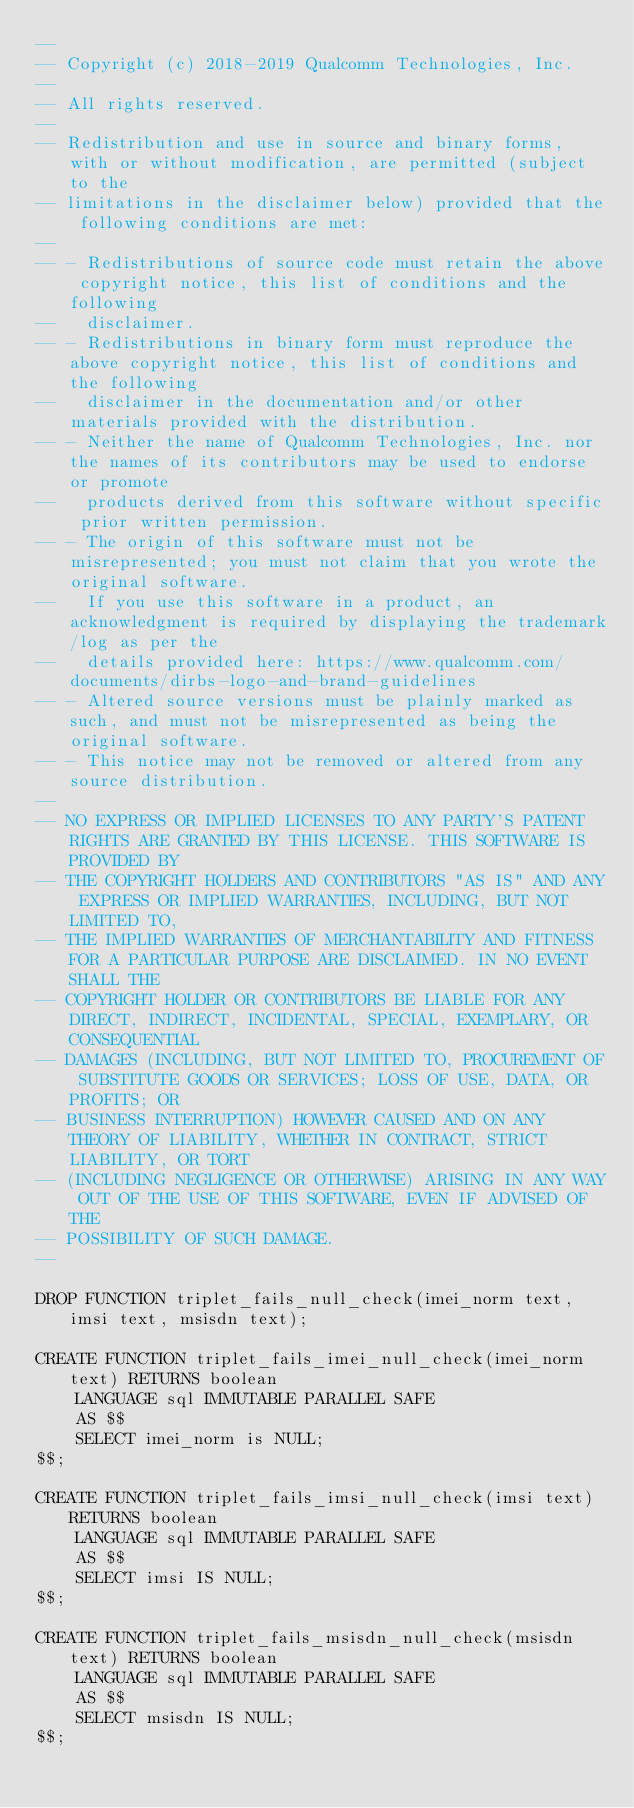<code> <loc_0><loc_0><loc_500><loc_500><_SQL_>--
-- Copyright (c) 2018-2019 Qualcomm Technologies, Inc.
--
-- All rights reserved.
--
-- Redistribution and use in source and binary forms, with or without modification, are permitted (subject to the
-- limitations in the disclaimer below) provided that the following conditions are met:
--
-- - Redistributions of source code must retain the above copyright notice, this list of conditions and the following
--   disclaimer.
-- - Redistributions in binary form must reproduce the above copyright notice, this list of conditions and the following
--   disclaimer in the documentation and/or other materials provided with the distribution.
-- - Neither the name of Qualcomm Technologies, Inc. nor the names of its contributors may be used to endorse or promote
--   products derived from this software without specific prior written permission.
-- - The origin of this software must not be misrepresented; you must not claim that you wrote the original software.
--   If you use this software in a product, an acknowledgment is required by displaying the trademark/log as per the
--   details provided here: https://www.qualcomm.com/documents/dirbs-logo-and-brand-guidelines
-- - Altered source versions must be plainly marked as such, and must not be misrepresented as being the original software.
-- - This notice may not be removed or altered from any source distribution.
--
-- NO EXPRESS OR IMPLIED LICENSES TO ANY PARTY'S PATENT RIGHTS ARE GRANTED BY THIS LICENSE. THIS SOFTWARE IS PROVIDED BY
-- THE COPYRIGHT HOLDERS AND CONTRIBUTORS "AS IS" AND ANY EXPRESS OR IMPLIED WARRANTIES, INCLUDING, BUT NOT LIMITED TO,
-- THE IMPLIED WARRANTIES OF MERCHANTABILITY AND FITNESS FOR A PARTICULAR PURPOSE ARE DISCLAIMED. IN NO EVENT SHALL THE
-- COPYRIGHT HOLDER OR CONTRIBUTORS BE LIABLE FOR ANY DIRECT, INDIRECT, INCIDENTAL, SPECIAL, EXEMPLARY, OR CONSEQUENTIAL
-- DAMAGES (INCLUDING, BUT NOT LIMITED TO, PROCUREMENT OF SUBSTITUTE GOODS OR SERVICES; LOSS OF USE, DATA, OR PROFITS; OR
-- BUSINESS INTERRUPTION) HOWEVER CAUSED AND ON ANY THEORY OF LIABILITY, WHETHER IN CONTRACT, STRICT LIABILITY, OR TORT
-- (INCLUDING NEGLIGENCE OR OTHERWISE) ARISING IN ANY WAY OUT OF THE USE OF THIS SOFTWARE, EVEN IF ADVISED OF THE
-- POSSIBILITY OF SUCH DAMAGE.
--

DROP FUNCTION triplet_fails_null_check(imei_norm text, imsi text, msisdn text);

CREATE FUNCTION triplet_fails_imei_null_check(imei_norm text) RETURNS boolean
    LANGUAGE sql IMMUTABLE PARALLEL SAFE
    AS $$
    SELECT imei_norm is NULL;
$$;

CREATE FUNCTION triplet_fails_imsi_null_check(imsi text) RETURNS boolean
    LANGUAGE sql IMMUTABLE PARALLEL SAFE
    AS $$
    SELECT imsi IS NULL;
$$;

CREATE FUNCTION triplet_fails_msisdn_null_check(msisdn text) RETURNS boolean
    LANGUAGE sql IMMUTABLE PARALLEL SAFE
    AS $$
    SELECT msisdn IS NULL;
$$;
</code> 